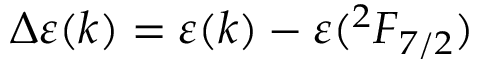Convert formula to latex. <formula><loc_0><loc_0><loc_500><loc_500>\Delta \varepsilon ( k ) = \varepsilon ( k ) - \varepsilon ( { ^ { 2 } F } _ { 7 / 2 } )</formula> 